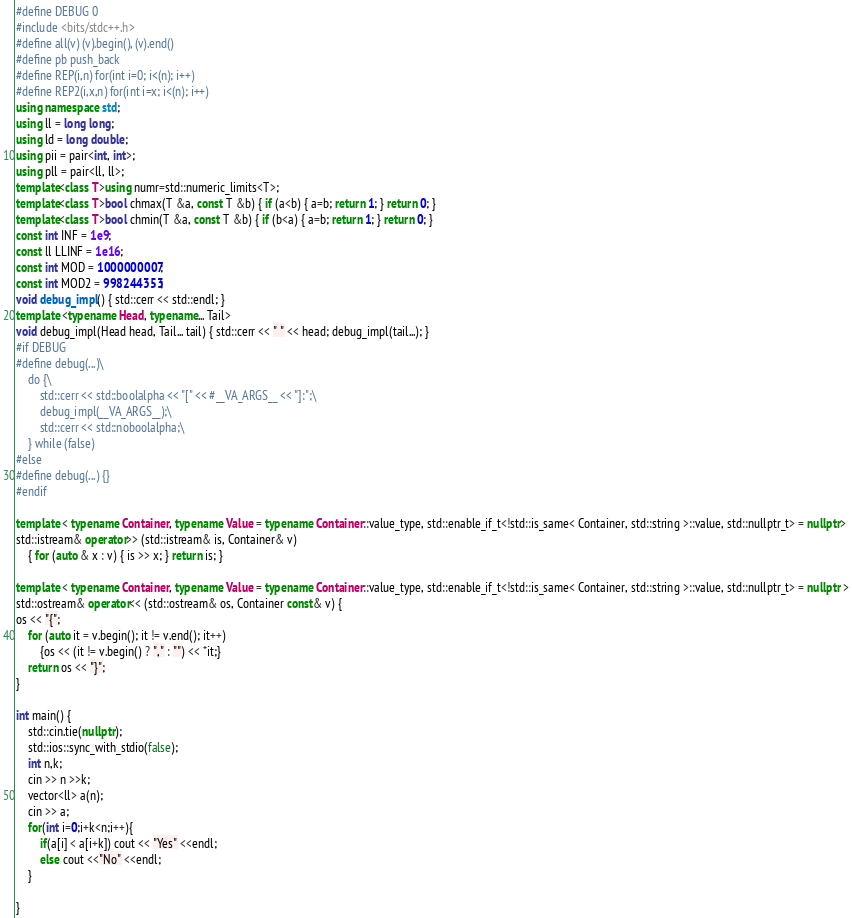Convert code to text. <code><loc_0><loc_0><loc_500><loc_500><_C++_>#define DEBUG 0
#include <bits/stdc++.h>
#define all(v) (v).begin(), (v).end()
#define pb push_back
#define REP(i,n) for(int i=0; i<(n); i++)
#define REP2(i,x,n) for(int i=x; i<(n); i++)
using namespace std;
using ll = long long;
using ld = long double;
using pii = pair<int, int>;
using pll = pair<ll, ll>;
template<class T>using numr=std::numeric_limits<T>;
template<class T>bool chmax(T &a, const T &b) { if (a<b) { a=b; return 1; } return 0; }
template<class T>bool chmin(T &a, const T &b) { if (b<a) { a=b; return 1; } return 0; }
const int INF = 1e9;
const ll LLINF = 1e16;
const int MOD = 1000000007;
const int MOD2 = 998244353;
void debug_impl() { std::cerr << std::endl; }
template <typename Head, typename... Tail>
void debug_impl(Head head, Tail... tail) { std::cerr << " " << head; debug_impl(tail...); }
#if DEBUG
#define debug(...)\
    do {\
        std::cerr << std::boolalpha << "[" << #__VA_ARGS__ << "]:";\
        debug_impl(__VA_ARGS__);\
        std::cerr << std::noboolalpha;\
    } while (false)
#else
#define debug(...) {}
#endif

template < typename Container, typename Value = typename Container::value_type, std::enable_if_t<!std::is_same< Container, std::string >::value, std::nullptr_t> = nullptr>
std::istream& operator>> (std::istream& is, Container& v)
    { for (auto & x : v) { is >> x; } return is; }

template < typename Container, typename Value = typename Container::value_type, std::enable_if_t<!std::is_same< Container, std::string >::value, std::nullptr_t> = nullptr >
std::ostream& operator<< (std::ostream& os, Container const& v) {
os << "{";
    for (auto it = v.begin(); it != v.end(); it++)
        {os << (it != v.begin() ? "," : "") << *it;}
    return os << "}";
}

int main() {
    std::cin.tie(nullptr);
    std::ios::sync_with_stdio(false);
    int n,k;
    cin >> n >>k;
    vector<ll> a(n);
    cin >> a;
    for(int i=0;i+k<n;i++){
        if(a[i] < a[i+k]) cout << "Yes" <<endl;
        else cout <<"No" <<endl;
    }

}</code> 